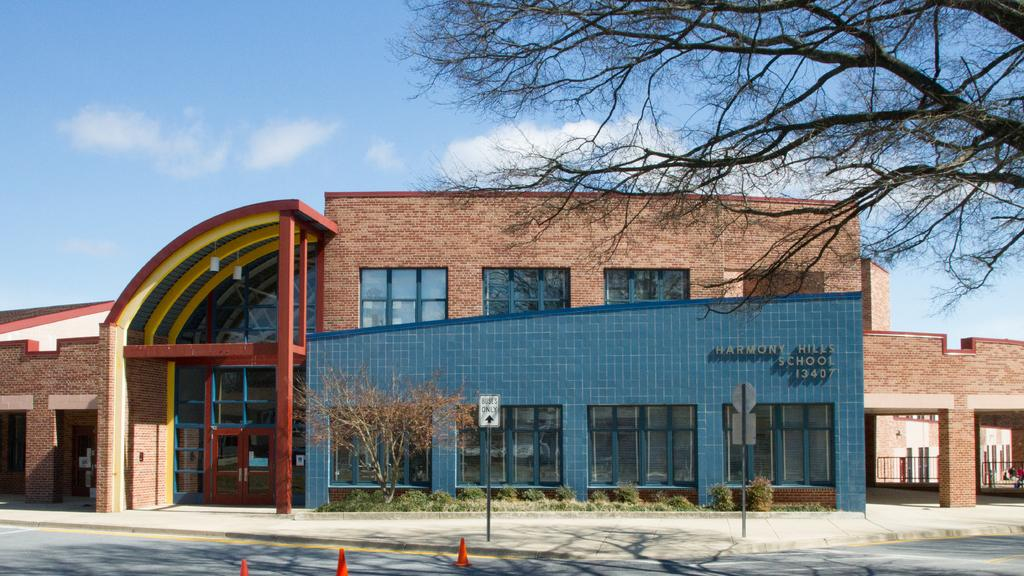What type of structure can be seen in the image? There is a building in the image. What is located in front of the building? Trees are present in front of the building. What type of signs are visible in the image? Sign boards are visible in the image. What type of material is used for the rods in the image? Metal rods are present in the image. What safety feature is visible in the image? Road divider cones are in the image. What can be seen in the background of the image? Clouds are visible in the background of the image. How many plastic health visitors are visible in the image? There are no plastic health visitors present in the image. 